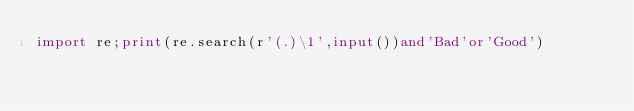<code> <loc_0><loc_0><loc_500><loc_500><_Python_>import re;print(re.search(r'(.)\1',input())and'Bad'or'Good')</code> 